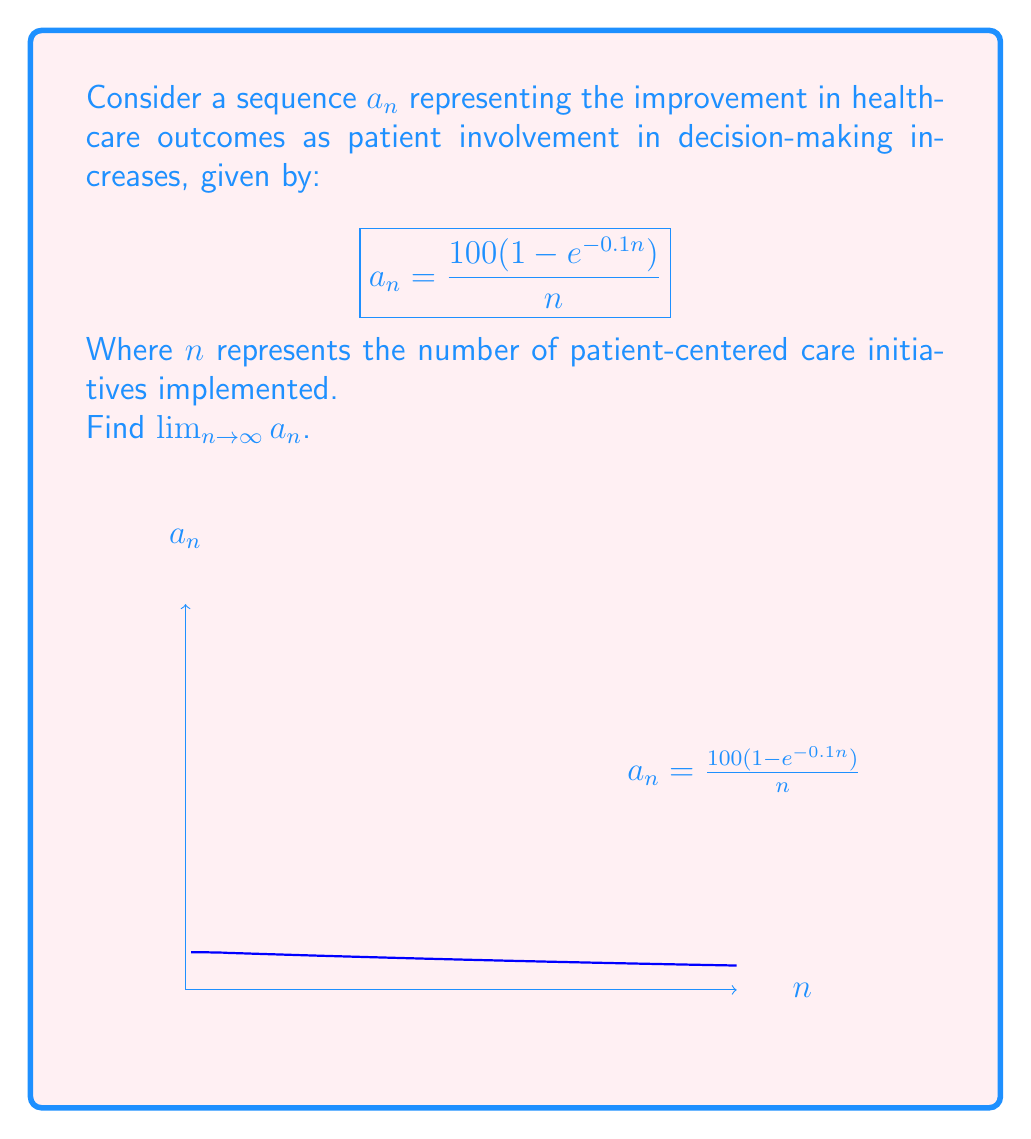Help me with this question. To find the limit of this sequence as $n$ approaches infinity, we can use L'Hôpital's rule:

1) First, we rewrite the sequence in a form suitable for L'Hôpital's rule:

   $$\lim_{n \to \infty} a_n = \lim_{n \to \infty} \frac{100(1 - e^{-0.1n})}{n}$$

2) Both numerator and denominator approach infinity as $n \to \infty$, so we can apply L'Hôpital's rule.

3) Differentiate both numerator and denominator with respect to $n$:

   $$\lim_{n \to \infty} \frac{100(0.1e^{-0.1n})}{1} = \lim_{n \to \infty} 10e^{-0.1n}$$

4) As $n$ approaches infinity, $e^{-0.1n}$ approaches 0:

   $$\lim_{n \to \infty} 10e^{-0.1n} = 10 \cdot 0 = 0$$

Therefore, the limit of the sequence as $n$ approaches infinity is 0.

This result suggests that as the number of patient-centered care initiatives increases indefinitely, the marginal improvement in healthcare outcomes diminishes, approaching zero in the limit.
Answer: $0$ 